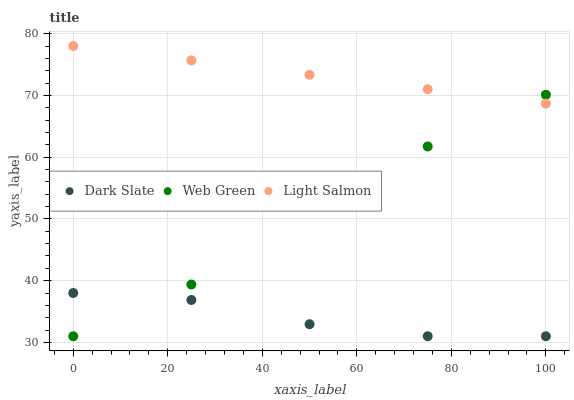Does Dark Slate have the minimum area under the curve?
Answer yes or no. Yes. Does Light Salmon have the maximum area under the curve?
Answer yes or no. Yes. Does Web Green have the minimum area under the curve?
Answer yes or no. No. Does Web Green have the maximum area under the curve?
Answer yes or no. No. Is Light Salmon the smoothest?
Answer yes or no. Yes. Is Web Green the roughest?
Answer yes or no. Yes. Is Web Green the smoothest?
Answer yes or no. No. Is Light Salmon the roughest?
Answer yes or no. No. Does Dark Slate have the lowest value?
Answer yes or no. Yes. Does Light Salmon have the lowest value?
Answer yes or no. No. Does Light Salmon have the highest value?
Answer yes or no. Yes. Does Web Green have the highest value?
Answer yes or no. No. Is Dark Slate less than Light Salmon?
Answer yes or no. Yes. Is Light Salmon greater than Dark Slate?
Answer yes or no. Yes. Does Web Green intersect Dark Slate?
Answer yes or no. Yes. Is Web Green less than Dark Slate?
Answer yes or no. No. Is Web Green greater than Dark Slate?
Answer yes or no. No. Does Dark Slate intersect Light Salmon?
Answer yes or no. No. 